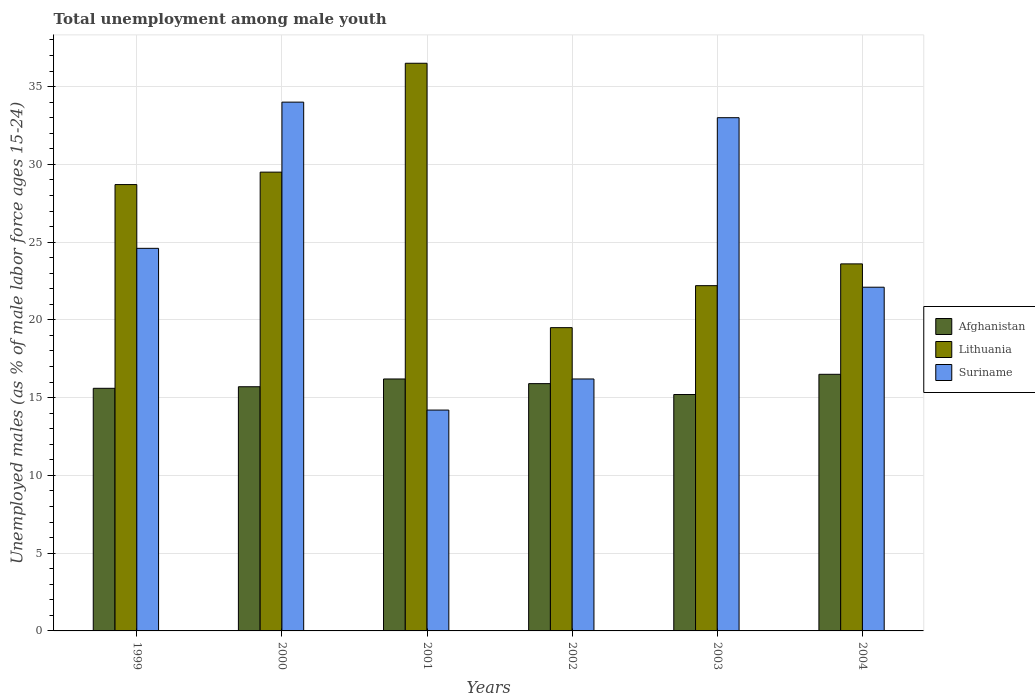How many different coloured bars are there?
Ensure brevity in your answer.  3. How many groups of bars are there?
Offer a very short reply. 6. Are the number of bars per tick equal to the number of legend labels?
Your answer should be very brief. Yes. How many bars are there on the 5th tick from the left?
Provide a succinct answer. 3. How many bars are there on the 4th tick from the right?
Keep it short and to the point. 3. What is the label of the 6th group of bars from the left?
Ensure brevity in your answer.  2004. In how many cases, is the number of bars for a given year not equal to the number of legend labels?
Keep it short and to the point. 0. What is the percentage of unemployed males in in Afghanistan in 2001?
Your response must be concise. 16.2. Across all years, what is the maximum percentage of unemployed males in in Lithuania?
Provide a short and direct response. 36.5. Across all years, what is the minimum percentage of unemployed males in in Lithuania?
Offer a very short reply. 19.5. In which year was the percentage of unemployed males in in Lithuania minimum?
Ensure brevity in your answer.  2002. What is the total percentage of unemployed males in in Suriname in the graph?
Offer a terse response. 144.1. What is the difference between the percentage of unemployed males in in Afghanistan in 2000 and that in 2002?
Offer a very short reply. -0.2. What is the difference between the percentage of unemployed males in in Afghanistan in 2002 and the percentage of unemployed males in in Lithuania in 1999?
Keep it short and to the point. -12.8. What is the average percentage of unemployed males in in Lithuania per year?
Keep it short and to the point. 26.67. In the year 1999, what is the difference between the percentage of unemployed males in in Suriname and percentage of unemployed males in in Afghanistan?
Your response must be concise. 9. In how many years, is the percentage of unemployed males in in Afghanistan greater than 28 %?
Ensure brevity in your answer.  0. What is the ratio of the percentage of unemployed males in in Afghanistan in 1999 to that in 2001?
Provide a succinct answer. 0.96. Is the difference between the percentage of unemployed males in in Suriname in 1999 and 2001 greater than the difference between the percentage of unemployed males in in Afghanistan in 1999 and 2001?
Your answer should be compact. Yes. In how many years, is the percentage of unemployed males in in Afghanistan greater than the average percentage of unemployed males in in Afghanistan taken over all years?
Offer a very short reply. 3. Is the sum of the percentage of unemployed males in in Afghanistan in 1999 and 2001 greater than the maximum percentage of unemployed males in in Lithuania across all years?
Give a very brief answer. No. What does the 1st bar from the left in 2003 represents?
Your response must be concise. Afghanistan. What does the 1st bar from the right in 2004 represents?
Make the answer very short. Suriname. Is it the case that in every year, the sum of the percentage of unemployed males in in Suriname and percentage of unemployed males in in Lithuania is greater than the percentage of unemployed males in in Afghanistan?
Provide a short and direct response. Yes. How many bars are there?
Keep it short and to the point. 18. Are all the bars in the graph horizontal?
Your answer should be very brief. No. How many years are there in the graph?
Offer a terse response. 6. Are the values on the major ticks of Y-axis written in scientific E-notation?
Your answer should be compact. No. Does the graph contain grids?
Provide a succinct answer. Yes. Where does the legend appear in the graph?
Your answer should be compact. Center right. How many legend labels are there?
Your answer should be compact. 3. What is the title of the graph?
Offer a terse response. Total unemployment among male youth. What is the label or title of the X-axis?
Give a very brief answer. Years. What is the label or title of the Y-axis?
Offer a very short reply. Unemployed males (as % of male labor force ages 15-24). What is the Unemployed males (as % of male labor force ages 15-24) of Afghanistan in 1999?
Give a very brief answer. 15.6. What is the Unemployed males (as % of male labor force ages 15-24) in Lithuania in 1999?
Your response must be concise. 28.7. What is the Unemployed males (as % of male labor force ages 15-24) in Suriname in 1999?
Keep it short and to the point. 24.6. What is the Unemployed males (as % of male labor force ages 15-24) in Afghanistan in 2000?
Ensure brevity in your answer.  15.7. What is the Unemployed males (as % of male labor force ages 15-24) of Lithuania in 2000?
Make the answer very short. 29.5. What is the Unemployed males (as % of male labor force ages 15-24) of Suriname in 2000?
Provide a succinct answer. 34. What is the Unemployed males (as % of male labor force ages 15-24) in Afghanistan in 2001?
Your answer should be compact. 16.2. What is the Unemployed males (as % of male labor force ages 15-24) in Lithuania in 2001?
Provide a succinct answer. 36.5. What is the Unemployed males (as % of male labor force ages 15-24) of Suriname in 2001?
Provide a short and direct response. 14.2. What is the Unemployed males (as % of male labor force ages 15-24) of Afghanistan in 2002?
Ensure brevity in your answer.  15.9. What is the Unemployed males (as % of male labor force ages 15-24) in Lithuania in 2002?
Give a very brief answer. 19.5. What is the Unemployed males (as % of male labor force ages 15-24) in Suriname in 2002?
Your answer should be very brief. 16.2. What is the Unemployed males (as % of male labor force ages 15-24) in Afghanistan in 2003?
Make the answer very short. 15.2. What is the Unemployed males (as % of male labor force ages 15-24) of Lithuania in 2003?
Your response must be concise. 22.2. What is the Unemployed males (as % of male labor force ages 15-24) of Suriname in 2003?
Offer a terse response. 33. What is the Unemployed males (as % of male labor force ages 15-24) in Lithuania in 2004?
Make the answer very short. 23.6. What is the Unemployed males (as % of male labor force ages 15-24) in Suriname in 2004?
Make the answer very short. 22.1. Across all years, what is the maximum Unemployed males (as % of male labor force ages 15-24) of Lithuania?
Give a very brief answer. 36.5. Across all years, what is the maximum Unemployed males (as % of male labor force ages 15-24) of Suriname?
Offer a very short reply. 34. Across all years, what is the minimum Unemployed males (as % of male labor force ages 15-24) in Afghanistan?
Offer a very short reply. 15.2. Across all years, what is the minimum Unemployed males (as % of male labor force ages 15-24) of Suriname?
Offer a very short reply. 14.2. What is the total Unemployed males (as % of male labor force ages 15-24) of Afghanistan in the graph?
Offer a terse response. 95.1. What is the total Unemployed males (as % of male labor force ages 15-24) of Lithuania in the graph?
Keep it short and to the point. 160. What is the total Unemployed males (as % of male labor force ages 15-24) of Suriname in the graph?
Provide a succinct answer. 144.1. What is the difference between the Unemployed males (as % of male labor force ages 15-24) of Suriname in 1999 and that in 2000?
Give a very brief answer. -9.4. What is the difference between the Unemployed males (as % of male labor force ages 15-24) in Afghanistan in 1999 and that in 2001?
Provide a succinct answer. -0.6. What is the difference between the Unemployed males (as % of male labor force ages 15-24) in Lithuania in 1999 and that in 2001?
Your answer should be very brief. -7.8. What is the difference between the Unemployed males (as % of male labor force ages 15-24) in Suriname in 1999 and that in 2001?
Ensure brevity in your answer.  10.4. What is the difference between the Unemployed males (as % of male labor force ages 15-24) of Lithuania in 1999 and that in 2002?
Offer a terse response. 9.2. What is the difference between the Unemployed males (as % of male labor force ages 15-24) in Afghanistan in 1999 and that in 2003?
Offer a very short reply. 0.4. What is the difference between the Unemployed males (as % of male labor force ages 15-24) in Suriname in 1999 and that in 2003?
Your answer should be very brief. -8.4. What is the difference between the Unemployed males (as % of male labor force ages 15-24) of Lithuania in 1999 and that in 2004?
Provide a short and direct response. 5.1. What is the difference between the Unemployed males (as % of male labor force ages 15-24) of Suriname in 1999 and that in 2004?
Keep it short and to the point. 2.5. What is the difference between the Unemployed males (as % of male labor force ages 15-24) in Afghanistan in 2000 and that in 2001?
Ensure brevity in your answer.  -0.5. What is the difference between the Unemployed males (as % of male labor force ages 15-24) in Lithuania in 2000 and that in 2001?
Make the answer very short. -7. What is the difference between the Unemployed males (as % of male labor force ages 15-24) of Suriname in 2000 and that in 2001?
Your response must be concise. 19.8. What is the difference between the Unemployed males (as % of male labor force ages 15-24) of Afghanistan in 2000 and that in 2002?
Your response must be concise. -0.2. What is the difference between the Unemployed males (as % of male labor force ages 15-24) in Suriname in 2000 and that in 2002?
Provide a short and direct response. 17.8. What is the difference between the Unemployed males (as % of male labor force ages 15-24) in Suriname in 2000 and that in 2003?
Make the answer very short. 1. What is the difference between the Unemployed males (as % of male labor force ages 15-24) of Suriname in 2001 and that in 2002?
Provide a short and direct response. -2. What is the difference between the Unemployed males (as % of male labor force ages 15-24) in Lithuania in 2001 and that in 2003?
Provide a short and direct response. 14.3. What is the difference between the Unemployed males (as % of male labor force ages 15-24) in Suriname in 2001 and that in 2003?
Your answer should be compact. -18.8. What is the difference between the Unemployed males (as % of male labor force ages 15-24) of Afghanistan in 2001 and that in 2004?
Keep it short and to the point. -0.3. What is the difference between the Unemployed males (as % of male labor force ages 15-24) of Lithuania in 2001 and that in 2004?
Provide a succinct answer. 12.9. What is the difference between the Unemployed males (as % of male labor force ages 15-24) in Suriname in 2001 and that in 2004?
Offer a very short reply. -7.9. What is the difference between the Unemployed males (as % of male labor force ages 15-24) in Suriname in 2002 and that in 2003?
Your answer should be very brief. -16.8. What is the difference between the Unemployed males (as % of male labor force ages 15-24) of Lithuania in 2002 and that in 2004?
Make the answer very short. -4.1. What is the difference between the Unemployed males (as % of male labor force ages 15-24) in Lithuania in 2003 and that in 2004?
Give a very brief answer. -1.4. What is the difference between the Unemployed males (as % of male labor force ages 15-24) in Suriname in 2003 and that in 2004?
Give a very brief answer. 10.9. What is the difference between the Unemployed males (as % of male labor force ages 15-24) in Afghanistan in 1999 and the Unemployed males (as % of male labor force ages 15-24) in Suriname in 2000?
Give a very brief answer. -18.4. What is the difference between the Unemployed males (as % of male labor force ages 15-24) in Afghanistan in 1999 and the Unemployed males (as % of male labor force ages 15-24) in Lithuania in 2001?
Provide a succinct answer. -20.9. What is the difference between the Unemployed males (as % of male labor force ages 15-24) of Afghanistan in 1999 and the Unemployed males (as % of male labor force ages 15-24) of Suriname in 2001?
Make the answer very short. 1.4. What is the difference between the Unemployed males (as % of male labor force ages 15-24) in Lithuania in 1999 and the Unemployed males (as % of male labor force ages 15-24) in Suriname in 2001?
Offer a very short reply. 14.5. What is the difference between the Unemployed males (as % of male labor force ages 15-24) in Afghanistan in 1999 and the Unemployed males (as % of male labor force ages 15-24) in Lithuania in 2002?
Give a very brief answer. -3.9. What is the difference between the Unemployed males (as % of male labor force ages 15-24) of Lithuania in 1999 and the Unemployed males (as % of male labor force ages 15-24) of Suriname in 2002?
Provide a succinct answer. 12.5. What is the difference between the Unemployed males (as % of male labor force ages 15-24) in Afghanistan in 1999 and the Unemployed males (as % of male labor force ages 15-24) in Suriname in 2003?
Provide a succinct answer. -17.4. What is the difference between the Unemployed males (as % of male labor force ages 15-24) in Lithuania in 1999 and the Unemployed males (as % of male labor force ages 15-24) in Suriname in 2003?
Your answer should be very brief. -4.3. What is the difference between the Unemployed males (as % of male labor force ages 15-24) in Afghanistan in 1999 and the Unemployed males (as % of male labor force ages 15-24) in Lithuania in 2004?
Provide a short and direct response. -8. What is the difference between the Unemployed males (as % of male labor force ages 15-24) in Afghanistan in 1999 and the Unemployed males (as % of male labor force ages 15-24) in Suriname in 2004?
Your answer should be compact. -6.5. What is the difference between the Unemployed males (as % of male labor force ages 15-24) of Lithuania in 1999 and the Unemployed males (as % of male labor force ages 15-24) of Suriname in 2004?
Give a very brief answer. 6.6. What is the difference between the Unemployed males (as % of male labor force ages 15-24) of Afghanistan in 2000 and the Unemployed males (as % of male labor force ages 15-24) of Lithuania in 2001?
Offer a very short reply. -20.8. What is the difference between the Unemployed males (as % of male labor force ages 15-24) in Afghanistan in 2000 and the Unemployed males (as % of male labor force ages 15-24) in Suriname in 2001?
Provide a succinct answer. 1.5. What is the difference between the Unemployed males (as % of male labor force ages 15-24) of Afghanistan in 2000 and the Unemployed males (as % of male labor force ages 15-24) of Suriname in 2002?
Provide a short and direct response. -0.5. What is the difference between the Unemployed males (as % of male labor force ages 15-24) in Lithuania in 2000 and the Unemployed males (as % of male labor force ages 15-24) in Suriname in 2002?
Offer a terse response. 13.3. What is the difference between the Unemployed males (as % of male labor force ages 15-24) of Afghanistan in 2000 and the Unemployed males (as % of male labor force ages 15-24) of Lithuania in 2003?
Offer a very short reply. -6.5. What is the difference between the Unemployed males (as % of male labor force ages 15-24) of Afghanistan in 2000 and the Unemployed males (as % of male labor force ages 15-24) of Suriname in 2003?
Provide a succinct answer. -17.3. What is the difference between the Unemployed males (as % of male labor force ages 15-24) in Lithuania in 2000 and the Unemployed males (as % of male labor force ages 15-24) in Suriname in 2003?
Ensure brevity in your answer.  -3.5. What is the difference between the Unemployed males (as % of male labor force ages 15-24) of Afghanistan in 2000 and the Unemployed males (as % of male labor force ages 15-24) of Lithuania in 2004?
Keep it short and to the point. -7.9. What is the difference between the Unemployed males (as % of male labor force ages 15-24) in Afghanistan in 2000 and the Unemployed males (as % of male labor force ages 15-24) in Suriname in 2004?
Provide a succinct answer. -6.4. What is the difference between the Unemployed males (as % of male labor force ages 15-24) of Lithuania in 2001 and the Unemployed males (as % of male labor force ages 15-24) of Suriname in 2002?
Offer a very short reply. 20.3. What is the difference between the Unemployed males (as % of male labor force ages 15-24) in Afghanistan in 2001 and the Unemployed males (as % of male labor force ages 15-24) in Lithuania in 2003?
Provide a succinct answer. -6. What is the difference between the Unemployed males (as % of male labor force ages 15-24) in Afghanistan in 2001 and the Unemployed males (as % of male labor force ages 15-24) in Suriname in 2003?
Offer a very short reply. -16.8. What is the difference between the Unemployed males (as % of male labor force ages 15-24) in Afghanistan in 2001 and the Unemployed males (as % of male labor force ages 15-24) in Lithuania in 2004?
Provide a short and direct response. -7.4. What is the difference between the Unemployed males (as % of male labor force ages 15-24) of Afghanistan in 2001 and the Unemployed males (as % of male labor force ages 15-24) of Suriname in 2004?
Offer a terse response. -5.9. What is the difference between the Unemployed males (as % of male labor force ages 15-24) in Lithuania in 2001 and the Unemployed males (as % of male labor force ages 15-24) in Suriname in 2004?
Ensure brevity in your answer.  14.4. What is the difference between the Unemployed males (as % of male labor force ages 15-24) in Afghanistan in 2002 and the Unemployed males (as % of male labor force ages 15-24) in Suriname in 2003?
Provide a short and direct response. -17.1. What is the difference between the Unemployed males (as % of male labor force ages 15-24) in Afghanistan in 2003 and the Unemployed males (as % of male labor force ages 15-24) in Lithuania in 2004?
Your answer should be compact. -8.4. What is the average Unemployed males (as % of male labor force ages 15-24) in Afghanistan per year?
Ensure brevity in your answer.  15.85. What is the average Unemployed males (as % of male labor force ages 15-24) of Lithuania per year?
Provide a succinct answer. 26.67. What is the average Unemployed males (as % of male labor force ages 15-24) in Suriname per year?
Ensure brevity in your answer.  24.02. In the year 1999, what is the difference between the Unemployed males (as % of male labor force ages 15-24) of Afghanistan and Unemployed males (as % of male labor force ages 15-24) of Lithuania?
Your answer should be compact. -13.1. In the year 2000, what is the difference between the Unemployed males (as % of male labor force ages 15-24) in Afghanistan and Unemployed males (as % of male labor force ages 15-24) in Lithuania?
Ensure brevity in your answer.  -13.8. In the year 2000, what is the difference between the Unemployed males (as % of male labor force ages 15-24) in Afghanistan and Unemployed males (as % of male labor force ages 15-24) in Suriname?
Keep it short and to the point. -18.3. In the year 2000, what is the difference between the Unemployed males (as % of male labor force ages 15-24) of Lithuania and Unemployed males (as % of male labor force ages 15-24) of Suriname?
Offer a terse response. -4.5. In the year 2001, what is the difference between the Unemployed males (as % of male labor force ages 15-24) in Afghanistan and Unemployed males (as % of male labor force ages 15-24) in Lithuania?
Provide a succinct answer. -20.3. In the year 2001, what is the difference between the Unemployed males (as % of male labor force ages 15-24) in Lithuania and Unemployed males (as % of male labor force ages 15-24) in Suriname?
Provide a succinct answer. 22.3. In the year 2002, what is the difference between the Unemployed males (as % of male labor force ages 15-24) in Afghanistan and Unemployed males (as % of male labor force ages 15-24) in Suriname?
Ensure brevity in your answer.  -0.3. In the year 2002, what is the difference between the Unemployed males (as % of male labor force ages 15-24) of Lithuania and Unemployed males (as % of male labor force ages 15-24) of Suriname?
Your response must be concise. 3.3. In the year 2003, what is the difference between the Unemployed males (as % of male labor force ages 15-24) in Afghanistan and Unemployed males (as % of male labor force ages 15-24) in Lithuania?
Keep it short and to the point. -7. In the year 2003, what is the difference between the Unemployed males (as % of male labor force ages 15-24) in Afghanistan and Unemployed males (as % of male labor force ages 15-24) in Suriname?
Provide a succinct answer. -17.8. In the year 2003, what is the difference between the Unemployed males (as % of male labor force ages 15-24) in Lithuania and Unemployed males (as % of male labor force ages 15-24) in Suriname?
Offer a very short reply. -10.8. In the year 2004, what is the difference between the Unemployed males (as % of male labor force ages 15-24) of Afghanistan and Unemployed males (as % of male labor force ages 15-24) of Lithuania?
Offer a very short reply. -7.1. In the year 2004, what is the difference between the Unemployed males (as % of male labor force ages 15-24) in Afghanistan and Unemployed males (as % of male labor force ages 15-24) in Suriname?
Give a very brief answer. -5.6. What is the ratio of the Unemployed males (as % of male labor force ages 15-24) of Afghanistan in 1999 to that in 2000?
Offer a terse response. 0.99. What is the ratio of the Unemployed males (as % of male labor force ages 15-24) in Lithuania in 1999 to that in 2000?
Your answer should be compact. 0.97. What is the ratio of the Unemployed males (as % of male labor force ages 15-24) in Suriname in 1999 to that in 2000?
Your answer should be compact. 0.72. What is the ratio of the Unemployed males (as % of male labor force ages 15-24) of Lithuania in 1999 to that in 2001?
Your response must be concise. 0.79. What is the ratio of the Unemployed males (as % of male labor force ages 15-24) of Suriname in 1999 to that in 2001?
Give a very brief answer. 1.73. What is the ratio of the Unemployed males (as % of male labor force ages 15-24) in Afghanistan in 1999 to that in 2002?
Your answer should be compact. 0.98. What is the ratio of the Unemployed males (as % of male labor force ages 15-24) of Lithuania in 1999 to that in 2002?
Your answer should be very brief. 1.47. What is the ratio of the Unemployed males (as % of male labor force ages 15-24) in Suriname in 1999 to that in 2002?
Your answer should be very brief. 1.52. What is the ratio of the Unemployed males (as % of male labor force ages 15-24) of Afghanistan in 1999 to that in 2003?
Your answer should be compact. 1.03. What is the ratio of the Unemployed males (as % of male labor force ages 15-24) of Lithuania in 1999 to that in 2003?
Offer a very short reply. 1.29. What is the ratio of the Unemployed males (as % of male labor force ages 15-24) in Suriname in 1999 to that in 2003?
Your answer should be very brief. 0.75. What is the ratio of the Unemployed males (as % of male labor force ages 15-24) of Afghanistan in 1999 to that in 2004?
Your answer should be compact. 0.95. What is the ratio of the Unemployed males (as % of male labor force ages 15-24) in Lithuania in 1999 to that in 2004?
Your answer should be compact. 1.22. What is the ratio of the Unemployed males (as % of male labor force ages 15-24) in Suriname in 1999 to that in 2004?
Your answer should be compact. 1.11. What is the ratio of the Unemployed males (as % of male labor force ages 15-24) of Afghanistan in 2000 to that in 2001?
Your response must be concise. 0.97. What is the ratio of the Unemployed males (as % of male labor force ages 15-24) of Lithuania in 2000 to that in 2001?
Your response must be concise. 0.81. What is the ratio of the Unemployed males (as % of male labor force ages 15-24) of Suriname in 2000 to that in 2001?
Provide a succinct answer. 2.39. What is the ratio of the Unemployed males (as % of male labor force ages 15-24) in Afghanistan in 2000 to that in 2002?
Provide a succinct answer. 0.99. What is the ratio of the Unemployed males (as % of male labor force ages 15-24) in Lithuania in 2000 to that in 2002?
Make the answer very short. 1.51. What is the ratio of the Unemployed males (as % of male labor force ages 15-24) of Suriname in 2000 to that in 2002?
Ensure brevity in your answer.  2.1. What is the ratio of the Unemployed males (as % of male labor force ages 15-24) of Afghanistan in 2000 to that in 2003?
Your response must be concise. 1.03. What is the ratio of the Unemployed males (as % of male labor force ages 15-24) of Lithuania in 2000 to that in 2003?
Ensure brevity in your answer.  1.33. What is the ratio of the Unemployed males (as % of male labor force ages 15-24) of Suriname in 2000 to that in 2003?
Make the answer very short. 1.03. What is the ratio of the Unemployed males (as % of male labor force ages 15-24) of Afghanistan in 2000 to that in 2004?
Your answer should be compact. 0.95. What is the ratio of the Unemployed males (as % of male labor force ages 15-24) in Lithuania in 2000 to that in 2004?
Give a very brief answer. 1.25. What is the ratio of the Unemployed males (as % of male labor force ages 15-24) of Suriname in 2000 to that in 2004?
Ensure brevity in your answer.  1.54. What is the ratio of the Unemployed males (as % of male labor force ages 15-24) of Afghanistan in 2001 to that in 2002?
Ensure brevity in your answer.  1.02. What is the ratio of the Unemployed males (as % of male labor force ages 15-24) in Lithuania in 2001 to that in 2002?
Your answer should be compact. 1.87. What is the ratio of the Unemployed males (as % of male labor force ages 15-24) of Suriname in 2001 to that in 2002?
Offer a terse response. 0.88. What is the ratio of the Unemployed males (as % of male labor force ages 15-24) of Afghanistan in 2001 to that in 2003?
Provide a short and direct response. 1.07. What is the ratio of the Unemployed males (as % of male labor force ages 15-24) of Lithuania in 2001 to that in 2003?
Ensure brevity in your answer.  1.64. What is the ratio of the Unemployed males (as % of male labor force ages 15-24) of Suriname in 2001 to that in 2003?
Give a very brief answer. 0.43. What is the ratio of the Unemployed males (as % of male labor force ages 15-24) of Afghanistan in 2001 to that in 2004?
Offer a very short reply. 0.98. What is the ratio of the Unemployed males (as % of male labor force ages 15-24) of Lithuania in 2001 to that in 2004?
Ensure brevity in your answer.  1.55. What is the ratio of the Unemployed males (as % of male labor force ages 15-24) in Suriname in 2001 to that in 2004?
Provide a succinct answer. 0.64. What is the ratio of the Unemployed males (as % of male labor force ages 15-24) of Afghanistan in 2002 to that in 2003?
Offer a terse response. 1.05. What is the ratio of the Unemployed males (as % of male labor force ages 15-24) of Lithuania in 2002 to that in 2003?
Your answer should be compact. 0.88. What is the ratio of the Unemployed males (as % of male labor force ages 15-24) in Suriname in 2002 to that in 2003?
Provide a short and direct response. 0.49. What is the ratio of the Unemployed males (as % of male labor force ages 15-24) of Afghanistan in 2002 to that in 2004?
Your answer should be compact. 0.96. What is the ratio of the Unemployed males (as % of male labor force ages 15-24) in Lithuania in 2002 to that in 2004?
Offer a terse response. 0.83. What is the ratio of the Unemployed males (as % of male labor force ages 15-24) in Suriname in 2002 to that in 2004?
Your response must be concise. 0.73. What is the ratio of the Unemployed males (as % of male labor force ages 15-24) in Afghanistan in 2003 to that in 2004?
Your response must be concise. 0.92. What is the ratio of the Unemployed males (as % of male labor force ages 15-24) in Lithuania in 2003 to that in 2004?
Provide a short and direct response. 0.94. What is the ratio of the Unemployed males (as % of male labor force ages 15-24) of Suriname in 2003 to that in 2004?
Provide a short and direct response. 1.49. What is the difference between the highest and the second highest Unemployed males (as % of male labor force ages 15-24) in Afghanistan?
Make the answer very short. 0.3. What is the difference between the highest and the second highest Unemployed males (as % of male labor force ages 15-24) of Lithuania?
Offer a very short reply. 7. What is the difference between the highest and the second highest Unemployed males (as % of male labor force ages 15-24) of Suriname?
Your answer should be very brief. 1. What is the difference between the highest and the lowest Unemployed males (as % of male labor force ages 15-24) of Afghanistan?
Keep it short and to the point. 1.3. What is the difference between the highest and the lowest Unemployed males (as % of male labor force ages 15-24) of Suriname?
Give a very brief answer. 19.8. 